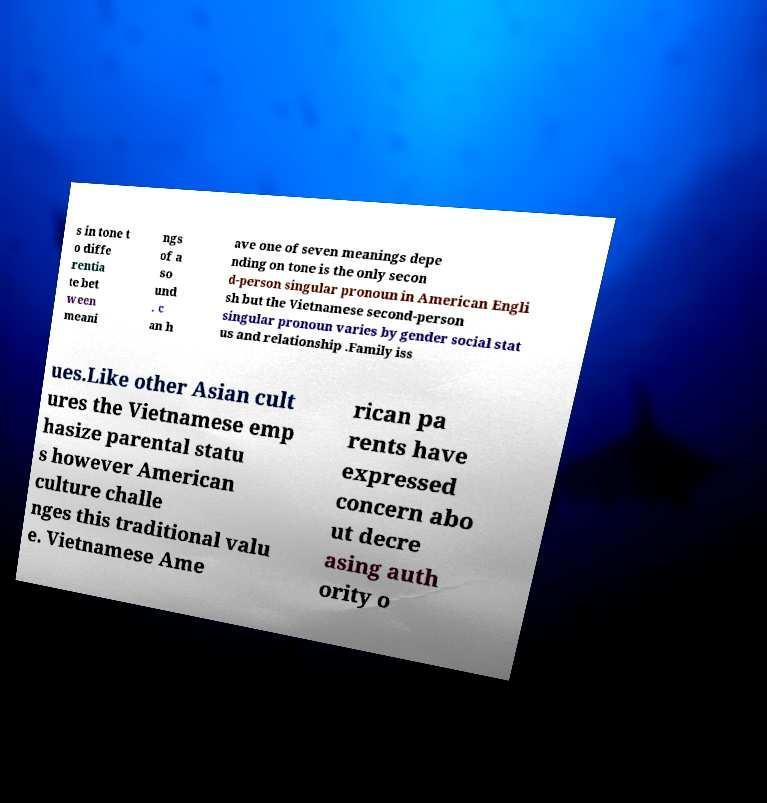Can you read and provide the text displayed in the image?This photo seems to have some interesting text. Can you extract and type it out for me? s in tone t o diffe rentia te bet ween meani ngs of a so und . c an h ave one of seven meanings depe nding on tone is the only secon d-person singular pronoun in American Engli sh but the Vietnamese second-person singular pronoun varies by gender social stat us and relationship .Family iss ues.Like other Asian cult ures the Vietnamese emp hasize parental statu s however American culture challe nges this traditional valu e. Vietnamese Ame rican pa rents have expressed concern abo ut decre asing auth ority o 